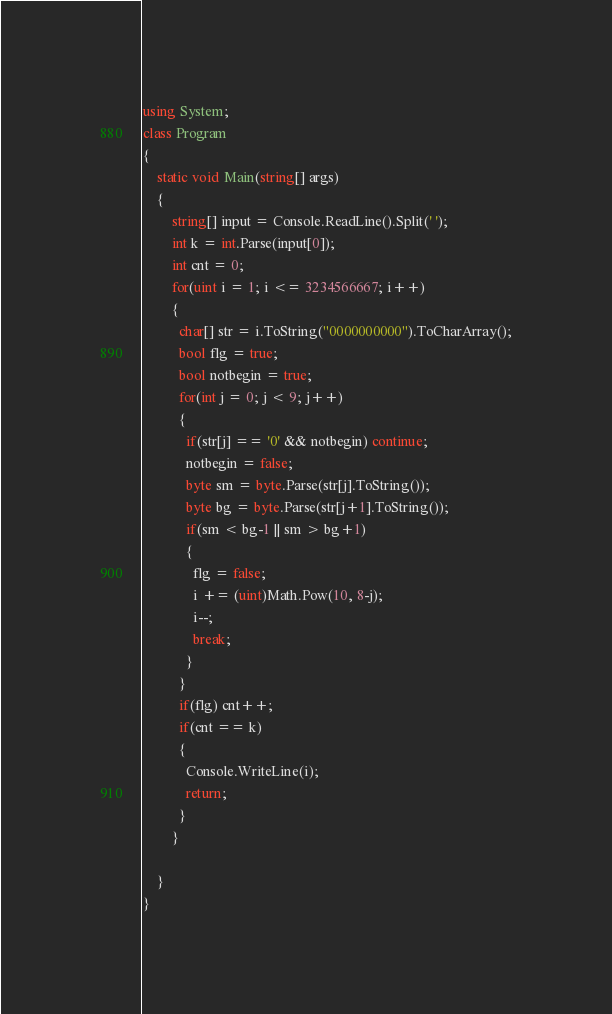Convert code to text. <code><loc_0><loc_0><loc_500><loc_500><_C#_>using System;
class Program
{
	static void Main(string[] args)
	{
		string[] input = Console.ReadLine().Split(' ');
		int k = int.Parse(input[0]);
        int cnt = 0;
        for(uint i = 1; i <= 3234566667; i++)
        {
          char[] str = i.ToString("0000000000").ToCharArray();
          bool flg = true;
          bool notbegin = true;
          for(int j = 0; j < 9; j++)
          {
            if(str[j] == '0' && notbegin) continue;
            notbegin = false;
            byte sm = byte.Parse(str[j].ToString());
            byte bg = byte.Parse(str[j+1].ToString());
            if(sm < bg-1 || sm > bg+1)
            {
              flg = false;
              i += (uint)Math.Pow(10, 8-j);
              i--;
              break;
            }
          }
          if(flg) cnt++;
          if(cnt == k)
          {
            Console.WriteLine(i);
            return;
          }
        }

	}
}</code> 